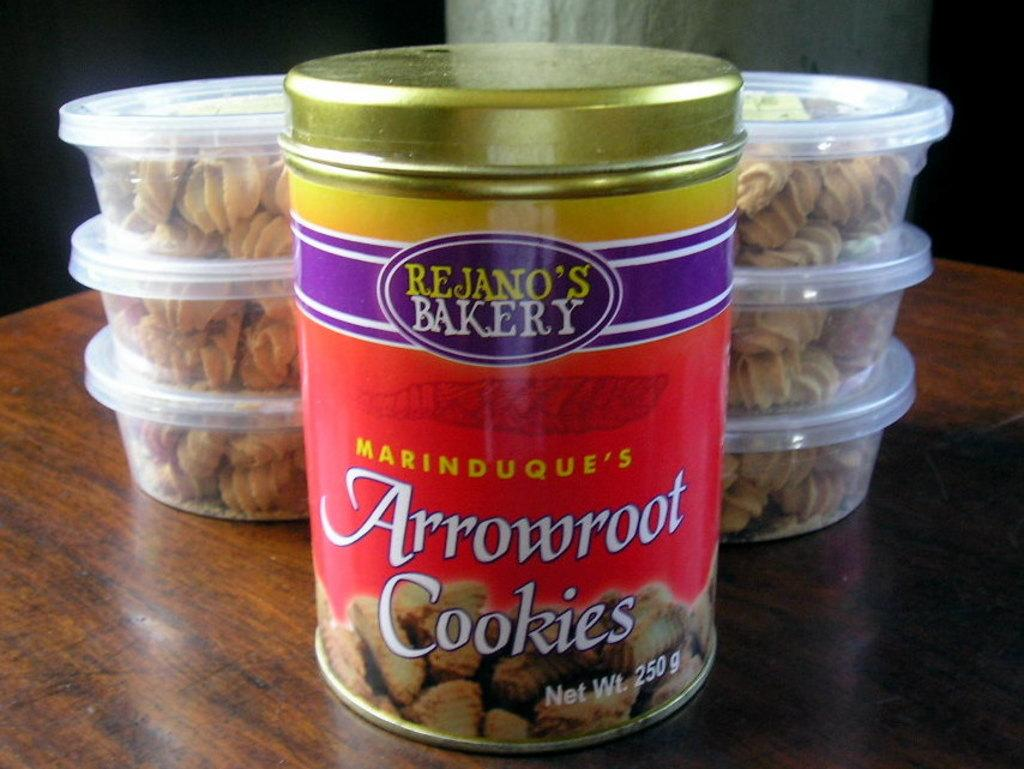What type of items are contained in the boxes in the image? There are boxes with food in the image. Can you describe the contents of the metal box in the image? The metal box contains cookies. Where are the boxes and the metal box located in the image? Both the boxes and the metal box are on a table. What type of lamp is present in the image? There is no lamp present in the image. What is the profit from the cookies in the metal box? The image does not provide information about the profit from the cookies; it only shows the metal box with cookies. 